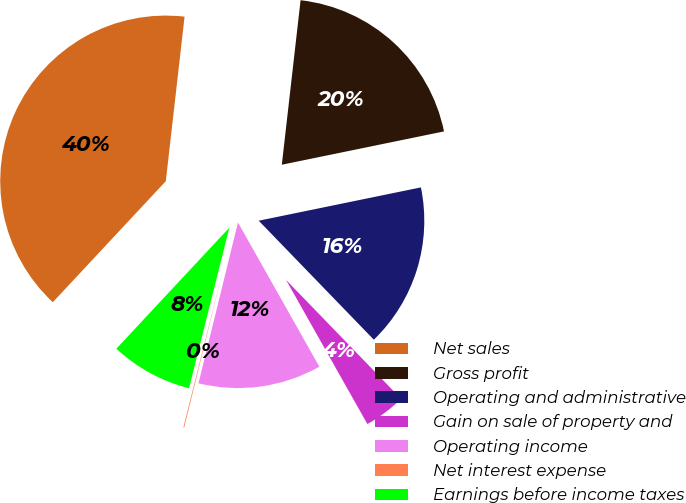Convert chart to OTSL. <chart><loc_0><loc_0><loc_500><loc_500><pie_chart><fcel>Net sales<fcel>Gross profit<fcel>Operating and administrative<fcel>Gain on sale of property and<fcel>Operating income<fcel>Net interest expense<fcel>Earnings before income taxes<nl><fcel>39.86%<fcel>19.97%<fcel>15.99%<fcel>4.06%<fcel>12.01%<fcel>0.08%<fcel>8.04%<nl></chart> 